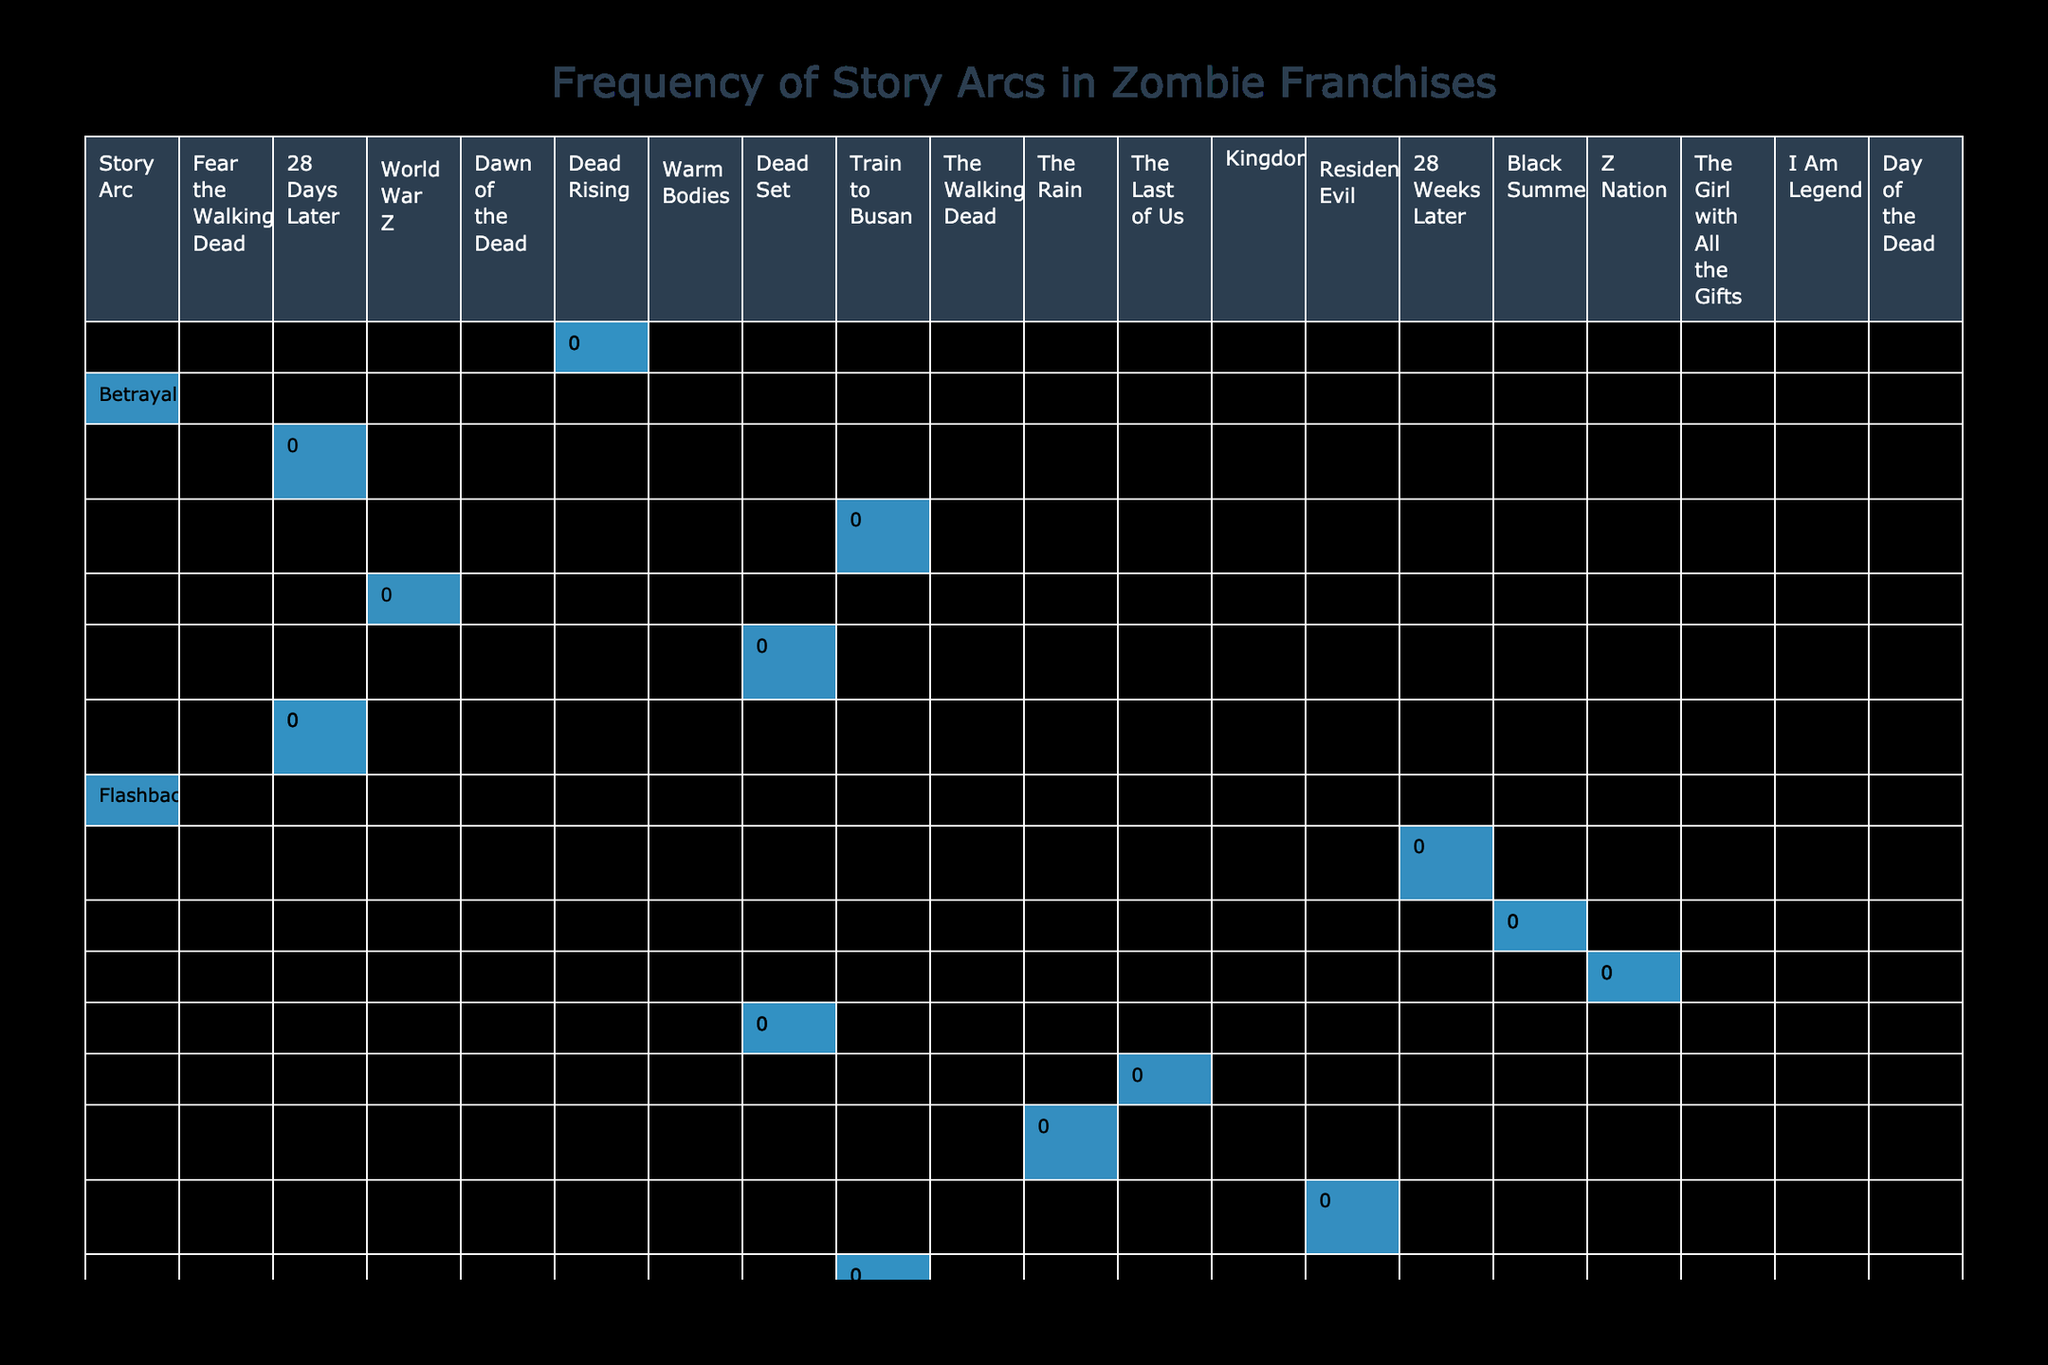What is the most frequently occurring plot point in "The Walking Dead"? The table shows that the plot point "Patient Zero" occurs once in "The Walking Dead." Since it is the only occurrence listed for that franchise, it stands as the most frequent plot point in that context.
Answer: 1 Which story arc has the highest frequency across all franchises? To find out, we should look for the maximum value in the frequency column. By checking the values, "Scavenging for Supplies" in "28 Days Later" has the highest frequency listed at 5.
Answer: 5 Does "World War Z" have a plot point with an impact score greater than 8? By inspecting the relevant row for "World War Z," I see that the plot point "Loss of Loved One" has an impact score of 8, which is not greater than 8. Therefore, the answer is no.
Answer: No What is the total frequency of plot points under the "Survival" story arc? First, we identify the rows under the "Survival" arc. There are two plot points: "Scavenging for Supplies" (5) and "Weapon Crafting" (4). Adding these gives us 5 + 4 = 9.
Answer: 9 Which franchise has the highest impact score for the plot point "Family Dynamics"? Looking at the impact score for "Family Dynamics", which is listed as 8 under "Train to Busan." Checking other franchises shows no other impacts from the family dynamics plot point, so "Train to Busan" has the highest score in this context.
Answer: Train to Busan What is the difference in the total frequencies of "Character Development" and "Conflict" story arcs? For "Character Development," the frequency from "World War Z" is 3 and the frequency from "The Walking Dead" is 2, giving a total of 3 + 2 = 5. For "Conflict," the only plot point listed is "Encounter with Hostile Survivors" from "Dawn of the Dead," which has a frequency of 4. The difference is 5 - 4 = 1.
Answer: 1 Does the "Z Nation" franchise feature a plot point that has both a low frequency and a low impact score? In "Z Nation," the plot points are "Potential Cure Discovery" (1, score 6) and "Rebuilding" (1, score 7). Since both plot points have low frequency (1) and neither has a high impact score, the answer is yes.
Answer: Yes What is the average impact score of plot points in the "Outbreak" story arc? There is only one plot point in the "Outbreak" arc, which is "Patient Zero," with an impact score of 9. Since there is only one score, the average (9) will remain the same.
Answer: 9 Which story arc has the lowest total frequency across all franchises? By reviewing the frequency values, several plot points are repeated with a frequency of 1 (including "Patient Zero," "Scientific Discovery," etc.), meaning multiple arcs share the lowest frequency. Thus, for this question, we say there is a tie among these arcs: "Outbreak," "Scientific Discovery," "Journey," "Hope," "Humanity," and "Societal Collapse."
Answer: Tie among several arcs 